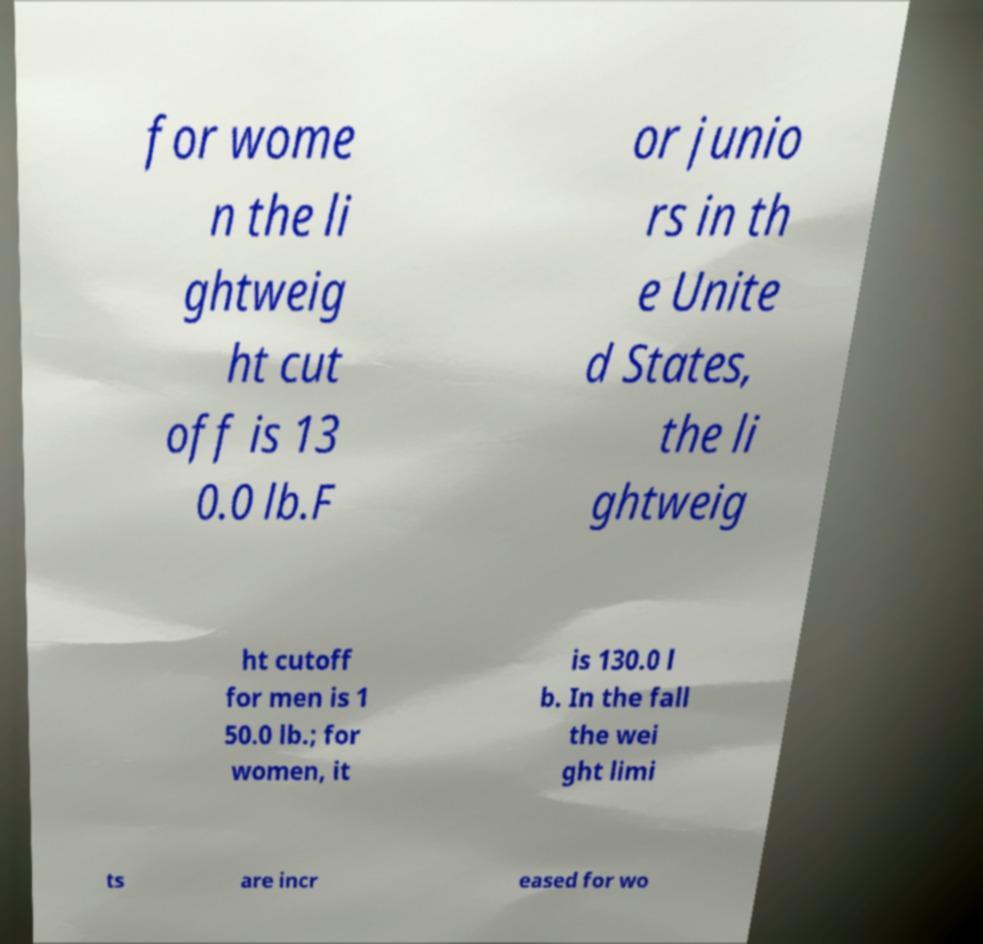What messages or text are displayed in this image? I need them in a readable, typed format. for wome n the li ghtweig ht cut off is 13 0.0 lb.F or junio rs in th e Unite d States, the li ghtweig ht cutoff for men is 1 50.0 lb.; for women, it is 130.0 l b. In the fall the wei ght limi ts are incr eased for wo 